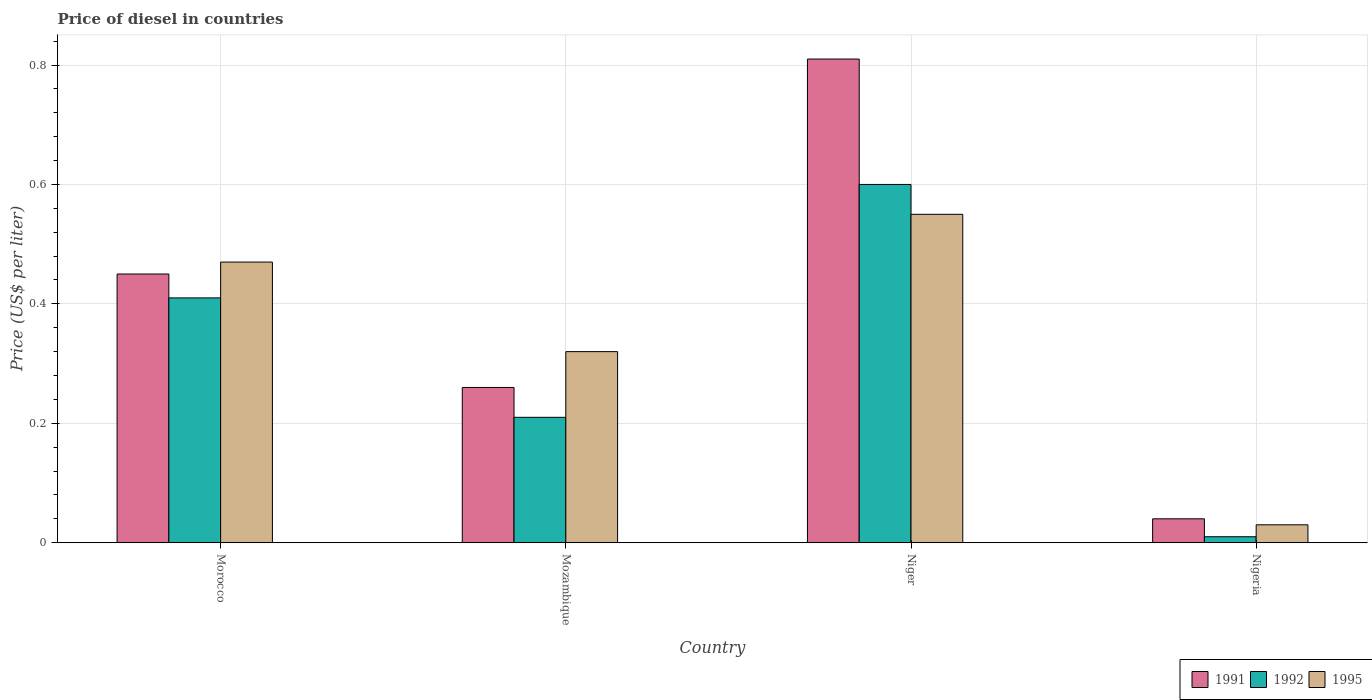How many groups of bars are there?
Your answer should be very brief. 4. Are the number of bars per tick equal to the number of legend labels?
Give a very brief answer. Yes. How many bars are there on the 3rd tick from the right?
Provide a succinct answer. 3. What is the label of the 1st group of bars from the left?
Your answer should be very brief. Morocco. What is the price of diesel in 1991 in Mozambique?
Your response must be concise. 0.26. In which country was the price of diesel in 1991 maximum?
Your response must be concise. Niger. In which country was the price of diesel in 1995 minimum?
Your answer should be compact. Nigeria. What is the total price of diesel in 1992 in the graph?
Give a very brief answer. 1.23. What is the difference between the price of diesel in 1995 in Mozambique and that in Niger?
Keep it short and to the point. -0.23. What is the difference between the price of diesel in 1991 in Mozambique and the price of diesel in 1992 in Morocco?
Offer a very short reply. -0.15. What is the average price of diesel in 1995 per country?
Offer a terse response. 0.34. Is the price of diesel in 1995 in Morocco less than that in Niger?
Provide a succinct answer. Yes. What is the difference between the highest and the second highest price of diesel in 1992?
Your answer should be compact. 0.39. What is the difference between the highest and the lowest price of diesel in 1991?
Keep it short and to the point. 0.77. What does the 1st bar from the right in Nigeria represents?
Make the answer very short. 1995. How many bars are there?
Provide a succinct answer. 12. What is the difference between two consecutive major ticks on the Y-axis?
Offer a terse response. 0.2. Does the graph contain any zero values?
Your response must be concise. No. Where does the legend appear in the graph?
Ensure brevity in your answer.  Bottom right. How many legend labels are there?
Keep it short and to the point. 3. What is the title of the graph?
Make the answer very short. Price of diesel in countries. What is the label or title of the Y-axis?
Provide a short and direct response. Price (US$ per liter). What is the Price (US$ per liter) of 1991 in Morocco?
Keep it short and to the point. 0.45. What is the Price (US$ per liter) of 1992 in Morocco?
Your answer should be compact. 0.41. What is the Price (US$ per liter) of 1995 in Morocco?
Provide a short and direct response. 0.47. What is the Price (US$ per liter) of 1991 in Mozambique?
Give a very brief answer. 0.26. What is the Price (US$ per liter) of 1992 in Mozambique?
Ensure brevity in your answer.  0.21. What is the Price (US$ per liter) in 1995 in Mozambique?
Keep it short and to the point. 0.32. What is the Price (US$ per liter) in 1991 in Niger?
Keep it short and to the point. 0.81. What is the Price (US$ per liter) in 1992 in Niger?
Ensure brevity in your answer.  0.6. What is the Price (US$ per liter) of 1995 in Niger?
Offer a very short reply. 0.55. What is the Price (US$ per liter) in 1992 in Nigeria?
Make the answer very short. 0.01. What is the Price (US$ per liter) in 1995 in Nigeria?
Your response must be concise. 0.03. Across all countries, what is the maximum Price (US$ per liter) in 1991?
Offer a very short reply. 0.81. Across all countries, what is the maximum Price (US$ per liter) in 1995?
Give a very brief answer. 0.55. Across all countries, what is the minimum Price (US$ per liter) of 1992?
Your answer should be very brief. 0.01. Across all countries, what is the minimum Price (US$ per liter) in 1995?
Ensure brevity in your answer.  0.03. What is the total Price (US$ per liter) of 1991 in the graph?
Provide a succinct answer. 1.56. What is the total Price (US$ per liter) of 1992 in the graph?
Keep it short and to the point. 1.23. What is the total Price (US$ per liter) of 1995 in the graph?
Provide a succinct answer. 1.37. What is the difference between the Price (US$ per liter) of 1991 in Morocco and that in Mozambique?
Make the answer very short. 0.19. What is the difference between the Price (US$ per liter) in 1995 in Morocco and that in Mozambique?
Give a very brief answer. 0.15. What is the difference between the Price (US$ per liter) of 1991 in Morocco and that in Niger?
Your answer should be compact. -0.36. What is the difference between the Price (US$ per liter) in 1992 in Morocco and that in Niger?
Give a very brief answer. -0.19. What is the difference between the Price (US$ per liter) of 1995 in Morocco and that in Niger?
Ensure brevity in your answer.  -0.08. What is the difference between the Price (US$ per liter) in 1991 in Morocco and that in Nigeria?
Provide a succinct answer. 0.41. What is the difference between the Price (US$ per liter) of 1995 in Morocco and that in Nigeria?
Give a very brief answer. 0.44. What is the difference between the Price (US$ per liter) in 1991 in Mozambique and that in Niger?
Provide a succinct answer. -0.55. What is the difference between the Price (US$ per liter) in 1992 in Mozambique and that in Niger?
Provide a succinct answer. -0.39. What is the difference between the Price (US$ per liter) in 1995 in Mozambique and that in Niger?
Keep it short and to the point. -0.23. What is the difference between the Price (US$ per liter) of 1991 in Mozambique and that in Nigeria?
Your answer should be very brief. 0.22. What is the difference between the Price (US$ per liter) in 1992 in Mozambique and that in Nigeria?
Offer a terse response. 0.2. What is the difference between the Price (US$ per liter) in 1995 in Mozambique and that in Nigeria?
Your response must be concise. 0.29. What is the difference between the Price (US$ per liter) of 1991 in Niger and that in Nigeria?
Provide a succinct answer. 0.77. What is the difference between the Price (US$ per liter) in 1992 in Niger and that in Nigeria?
Make the answer very short. 0.59. What is the difference between the Price (US$ per liter) in 1995 in Niger and that in Nigeria?
Provide a short and direct response. 0.52. What is the difference between the Price (US$ per liter) of 1991 in Morocco and the Price (US$ per liter) of 1992 in Mozambique?
Provide a succinct answer. 0.24. What is the difference between the Price (US$ per liter) in 1991 in Morocco and the Price (US$ per liter) in 1995 in Mozambique?
Keep it short and to the point. 0.13. What is the difference between the Price (US$ per liter) of 1992 in Morocco and the Price (US$ per liter) of 1995 in Mozambique?
Offer a terse response. 0.09. What is the difference between the Price (US$ per liter) of 1991 in Morocco and the Price (US$ per liter) of 1992 in Niger?
Offer a very short reply. -0.15. What is the difference between the Price (US$ per liter) of 1991 in Morocco and the Price (US$ per liter) of 1995 in Niger?
Offer a very short reply. -0.1. What is the difference between the Price (US$ per liter) of 1992 in Morocco and the Price (US$ per liter) of 1995 in Niger?
Provide a short and direct response. -0.14. What is the difference between the Price (US$ per liter) in 1991 in Morocco and the Price (US$ per liter) in 1992 in Nigeria?
Give a very brief answer. 0.44. What is the difference between the Price (US$ per liter) of 1991 in Morocco and the Price (US$ per liter) of 1995 in Nigeria?
Offer a terse response. 0.42. What is the difference between the Price (US$ per liter) of 1992 in Morocco and the Price (US$ per liter) of 1995 in Nigeria?
Give a very brief answer. 0.38. What is the difference between the Price (US$ per liter) of 1991 in Mozambique and the Price (US$ per liter) of 1992 in Niger?
Keep it short and to the point. -0.34. What is the difference between the Price (US$ per liter) of 1991 in Mozambique and the Price (US$ per liter) of 1995 in Niger?
Your response must be concise. -0.29. What is the difference between the Price (US$ per liter) of 1992 in Mozambique and the Price (US$ per liter) of 1995 in Niger?
Ensure brevity in your answer.  -0.34. What is the difference between the Price (US$ per liter) in 1991 in Mozambique and the Price (US$ per liter) in 1995 in Nigeria?
Keep it short and to the point. 0.23. What is the difference between the Price (US$ per liter) in 1992 in Mozambique and the Price (US$ per liter) in 1995 in Nigeria?
Provide a short and direct response. 0.18. What is the difference between the Price (US$ per liter) in 1991 in Niger and the Price (US$ per liter) in 1992 in Nigeria?
Give a very brief answer. 0.8. What is the difference between the Price (US$ per liter) of 1991 in Niger and the Price (US$ per liter) of 1995 in Nigeria?
Offer a very short reply. 0.78. What is the difference between the Price (US$ per liter) in 1992 in Niger and the Price (US$ per liter) in 1995 in Nigeria?
Offer a terse response. 0.57. What is the average Price (US$ per liter) of 1991 per country?
Ensure brevity in your answer.  0.39. What is the average Price (US$ per liter) of 1992 per country?
Offer a very short reply. 0.31. What is the average Price (US$ per liter) of 1995 per country?
Your answer should be very brief. 0.34. What is the difference between the Price (US$ per liter) in 1991 and Price (US$ per liter) in 1995 in Morocco?
Your answer should be compact. -0.02. What is the difference between the Price (US$ per liter) in 1992 and Price (US$ per liter) in 1995 in Morocco?
Give a very brief answer. -0.06. What is the difference between the Price (US$ per liter) in 1991 and Price (US$ per liter) in 1995 in Mozambique?
Ensure brevity in your answer.  -0.06. What is the difference between the Price (US$ per liter) in 1992 and Price (US$ per liter) in 1995 in Mozambique?
Provide a short and direct response. -0.11. What is the difference between the Price (US$ per liter) in 1991 and Price (US$ per liter) in 1992 in Niger?
Ensure brevity in your answer.  0.21. What is the difference between the Price (US$ per liter) in 1991 and Price (US$ per liter) in 1995 in Niger?
Give a very brief answer. 0.26. What is the difference between the Price (US$ per liter) in 1992 and Price (US$ per liter) in 1995 in Nigeria?
Give a very brief answer. -0.02. What is the ratio of the Price (US$ per liter) in 1991 in Morocco to that in Mozambique?
Your response must be concise. 1.73. What is the ratio of the Price (US$ per liter) of 1992 in Morocco to that in Mozambique?
Provide a short and direct response. 1.95. What is the ratio of the Price (US$ per liter) in 1995 in Morocco to that in Mozambique?
Make the answer very short. 1.47. What is the ratio of the Price (US$ per liter) in 1991 in Morocco to that in Niger?
Your response must be concise. 0.56. What is the ratio of the Price (US$ per liter) of 1992 in Morocco to that in Niger?
Your response must be concise. 0.68. What is the ratio of the Price (US$ per liter) in 1995 in Morocco to that in Niger?
Make the answer very short. 0.85. What is the ratio of the Price (US$ per liter) in 1991 in Morocco to that in Nigeria?
Make the answer very short. 11.25. What is the ratio of the Price (US$ per liter) of 1992 in Morocco to that in Nigeria?
Keep it short and to the point. 41. What is the ratio of the Price (US$ per liter) in 1995 in Morocco to that in Nigeria?
Your answer should be compact. 15.67. What is the ratio of the Price (US$ per liter) in 1991 in Mozambique to that in Niger?
Offer a terse response. 0.32. What is the ratio of the Price (US$ per liter) of 1992 in Mozambique to that in Niger?
Keep it short and to the point. 0.35. What is the ratio of the Price (US$ per liter) in 1995 in Mozambique to that in Niger?
Offer a terse response. 0.58. What is the ratio of the Price (US$ per liter) of 1995 in Mozambique to that in Nigeria?
Your response must be concise. 10.67. What is the ratio of the Price (US$ per liter) of 1991 in Niger to that in Nigeria?
Ensure brevity in your answer.  20.25. What is the ratio of the Price (US$ per liter) of 1995 in Niger to that in Nigeria?
Ensure brevity in your answer.  18.33. What is the difference between the highest and the second highest Price (US$ per liter) of 1991?
Give a very brief answer. 0.36. What is the difference between the highest and the second highest Price (US$ per liter) in 1992?
Give a very brief answer. 0.19. What is the difference between the highest and the second highest Price (US$ per liter) of 1995?
Keep it short and to the point. 0.08. What is the difference between the highest and the lowest Price (US$ per liter) of 1991?
Keep it short and to the point. 0.77. What is the difference between the highest and the lowest Price (US$ per liter) of 1992?
Offer a terse response. 0.59. What is the difference between the highest and the lowest Price (US$ per liter) in 1995?
Provide a short and direct response. 0.52. 